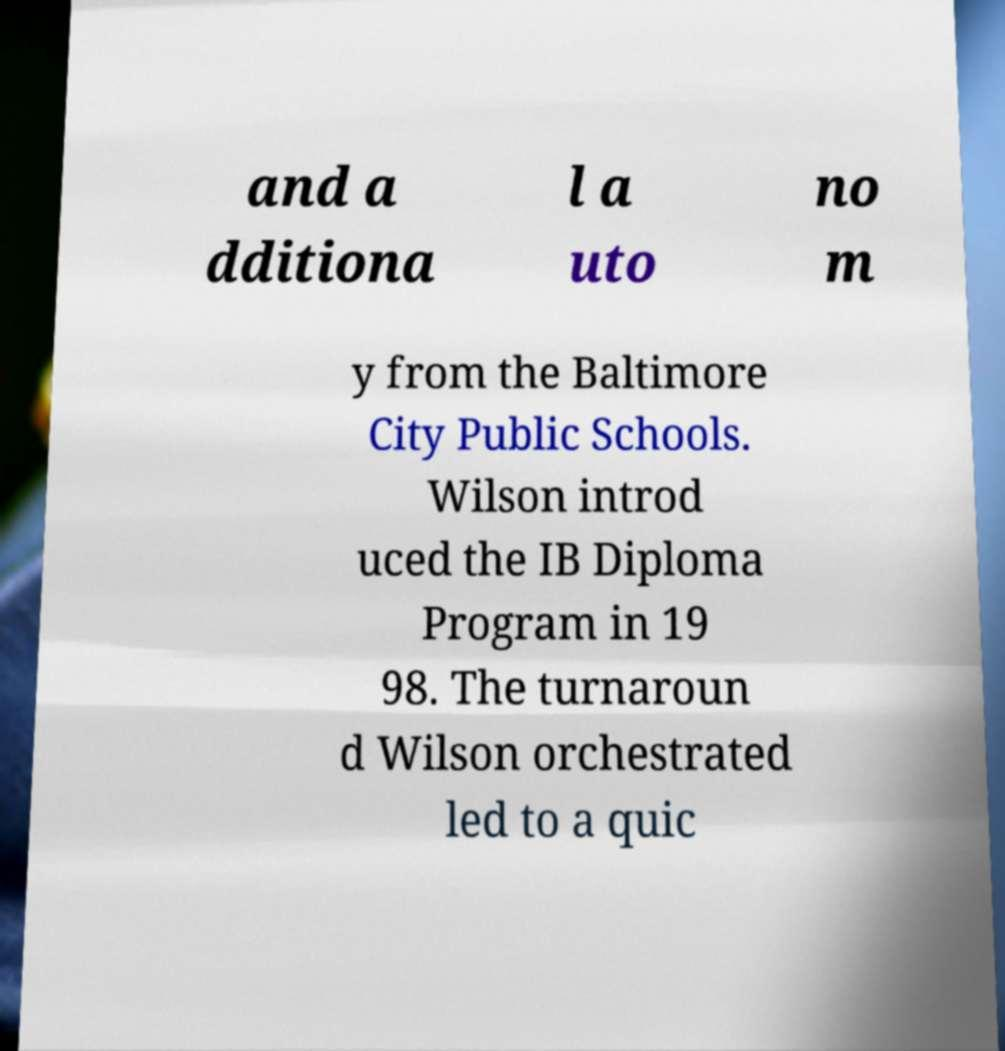Please identify and transcribe the text found in this image. and a dditiona l a uto no m y from the Baltimore City Public Schools. Wilson introd uced the IB Diploma Program in 19 98. The turnaroun d Wilson orchestrated led to a quic 